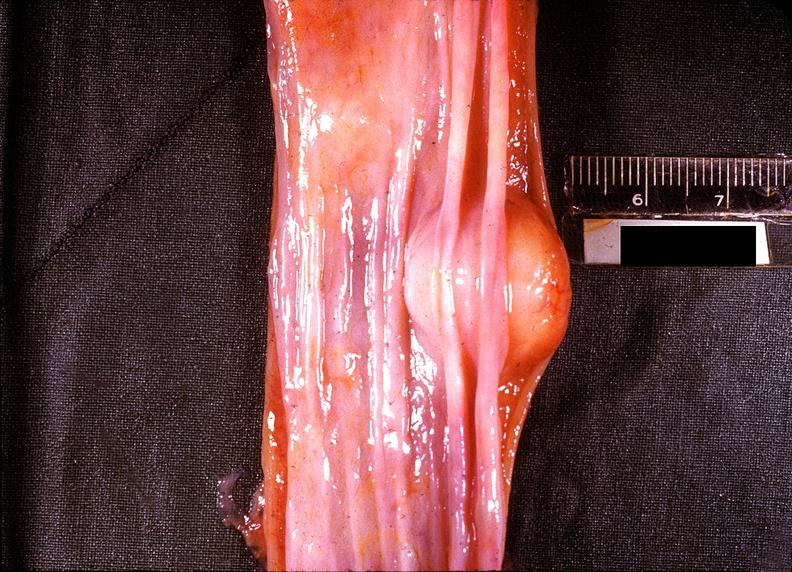does another fiber other frame show esophagus, leiomyoma?
Answer the question using a single word or phrase. No 